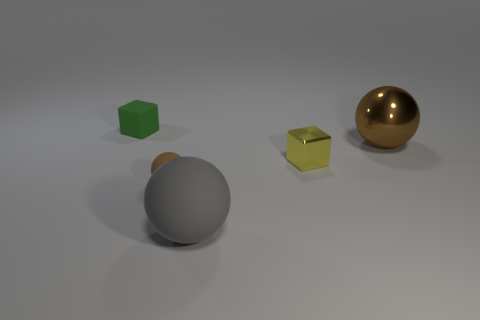Are these objects arranged in a pattern or randomly? The objects appear to be arranged randomly, with no discernible pattern in terms of size, color, or spacing. 